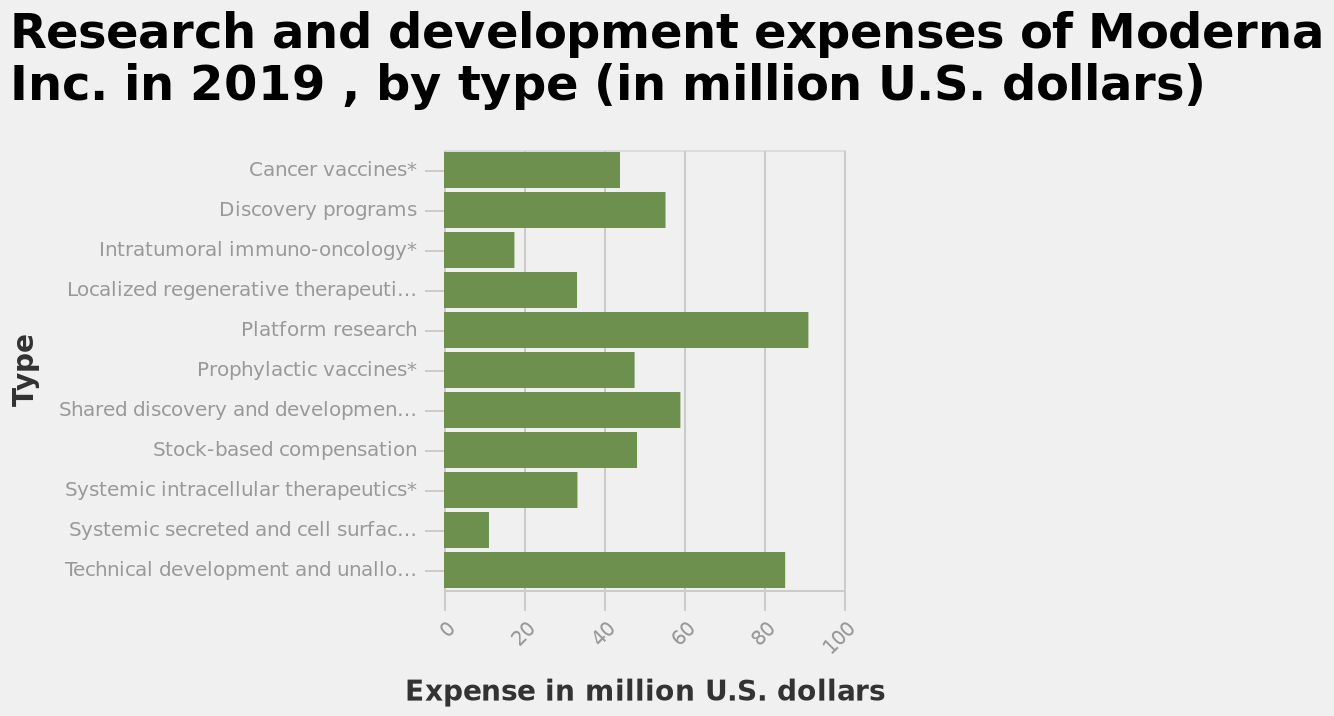<image>
How much money was spent on lesser expenses in modern development? Lesser expenses in modern development accounted for 10/20 million dollars. please enumerates aspects of the construction of the chart Research and development expenses of Moderna Inc. in 2019 , by type (in million U.S. dollars) is a bar diagram. The x-axis shows Expense in million U.S. dollars with linear scale from 0 to 100 while the y-axis shows Type along categorical scale starting at Cancer vaccines* and ending at Technical development and unallocated manufacturing expenses. How much money was spent on mid-range expenses in modern development?  Around 40 million dollars was spent on mid-range expenses in modern development. 